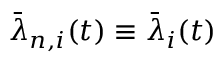Convert formula to latex. <formula><loc_0><loc_0><loc_500><loc_500>\bar { \lambda } _ { n , i } ( t ) \equiv \bar { \lambda } _ { i } ( t )</formula> 